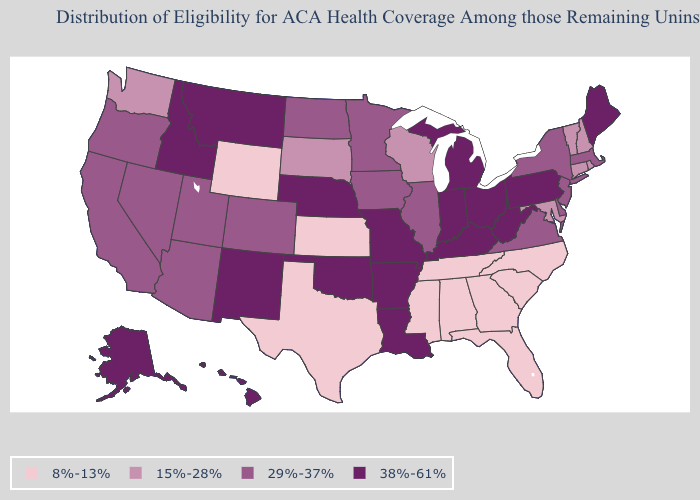Among the states that border Mississippi , does Tennessee have the lowest value?
Answer briefly. Yes. What is the value of Alabama?
Answer briefly. 8%-13%. What is the highest value in the USA?
Quick response, please. 38%-61%. What is the value of Washington?
Concise answer only. 15%-28%. What is the value of Connecticut?
Answer briefly. 15%-28%. Name the states that have a value in the range 29%-37%?
Write a very short answer. Arizona, California, Colorado, Delaware, Illinois, Iowa, Massachusetts, Minnesota, Nevada, New Jersey, New York, North Dakota, Oregon, Utah, Virginia. What is the value of Virginia?
Write a very short answer. 29%-37%. What is the value of New Mexico?
Give a very brief answer. 38%-61%. Name the states that have a value in the range 29%-37%?
Answer briefly. Arizona, California, Colorado, Delaware, Illinois, Iowa, Massachusetts, Minnesota, Nevada, New Jersey, New York, North Dakota, Oregon, Utah, Virginia. What is the lowest value in the USA?
Be succinct. 8%-13%. Does North Dakota have the lowest value in the MidWest?
Keep it brief. No. Does Florida have the same value as Tennessee?
Answer briefly. Yes. Name the states that have a value in the range 38%-61%?
Be succinct. Alaska, Arkansas, Hawaii, Idaho, Indiana, Kentucky, Louisiana, Maine, Michigan, Missouri, Montana, Nebraska, New Mexico, Ohio, Oklahoma, Pennsylvania, West Virginia. Does the map have missing data?
Quick response, please. No. What is the value of Indiana?
Concise answer only. 38%-61%. 